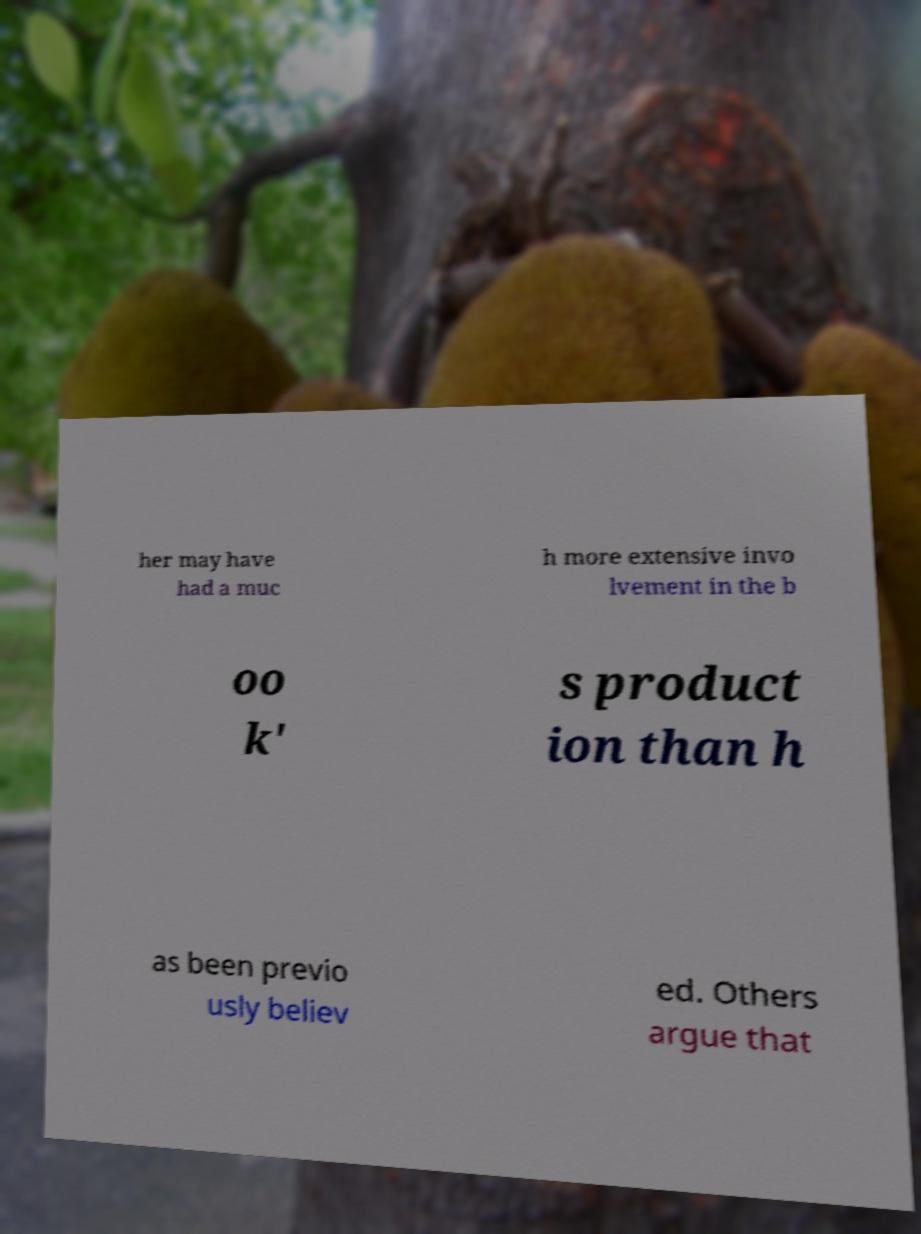Please identify and transcribe the text found in this image. her may have had a muc h more extensive invo lvement in the b oo k' s product ion than h as been previo usly believ ed. Others argue that 